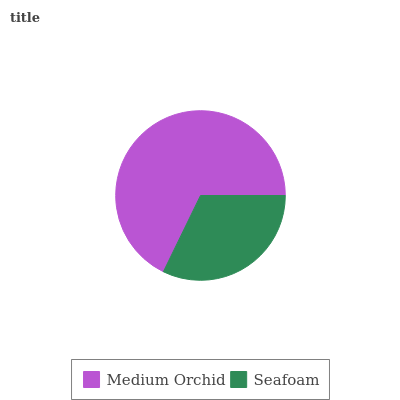Is Seafoam the minimum?
Answer yes or no. Yes. Is Medium Orchid the maximum?
Answer yes or no. Yes. Is Seafoam the maximum?
Answer yes or no. No. Is Medium Orchid greater than Seafoam?
Answer yes or no. Yes. Is Seafoam less than Medium Orchid?
Answer yes or no. Yes. Is Seafoam greater than Medium Orchid?
Answer yes or no. No. Is Medium Orchid less than Seafoam?
Answer yes or no. No. Is Medium Orchid the high median?
Answer yes or no. Yes. Is Seafoam the low median?
Answer yes or no. Yes. Is Seafoam the high median?
Answer yes or no. No. Is Medium Orchid the low median?
Answer yes or no. No. 